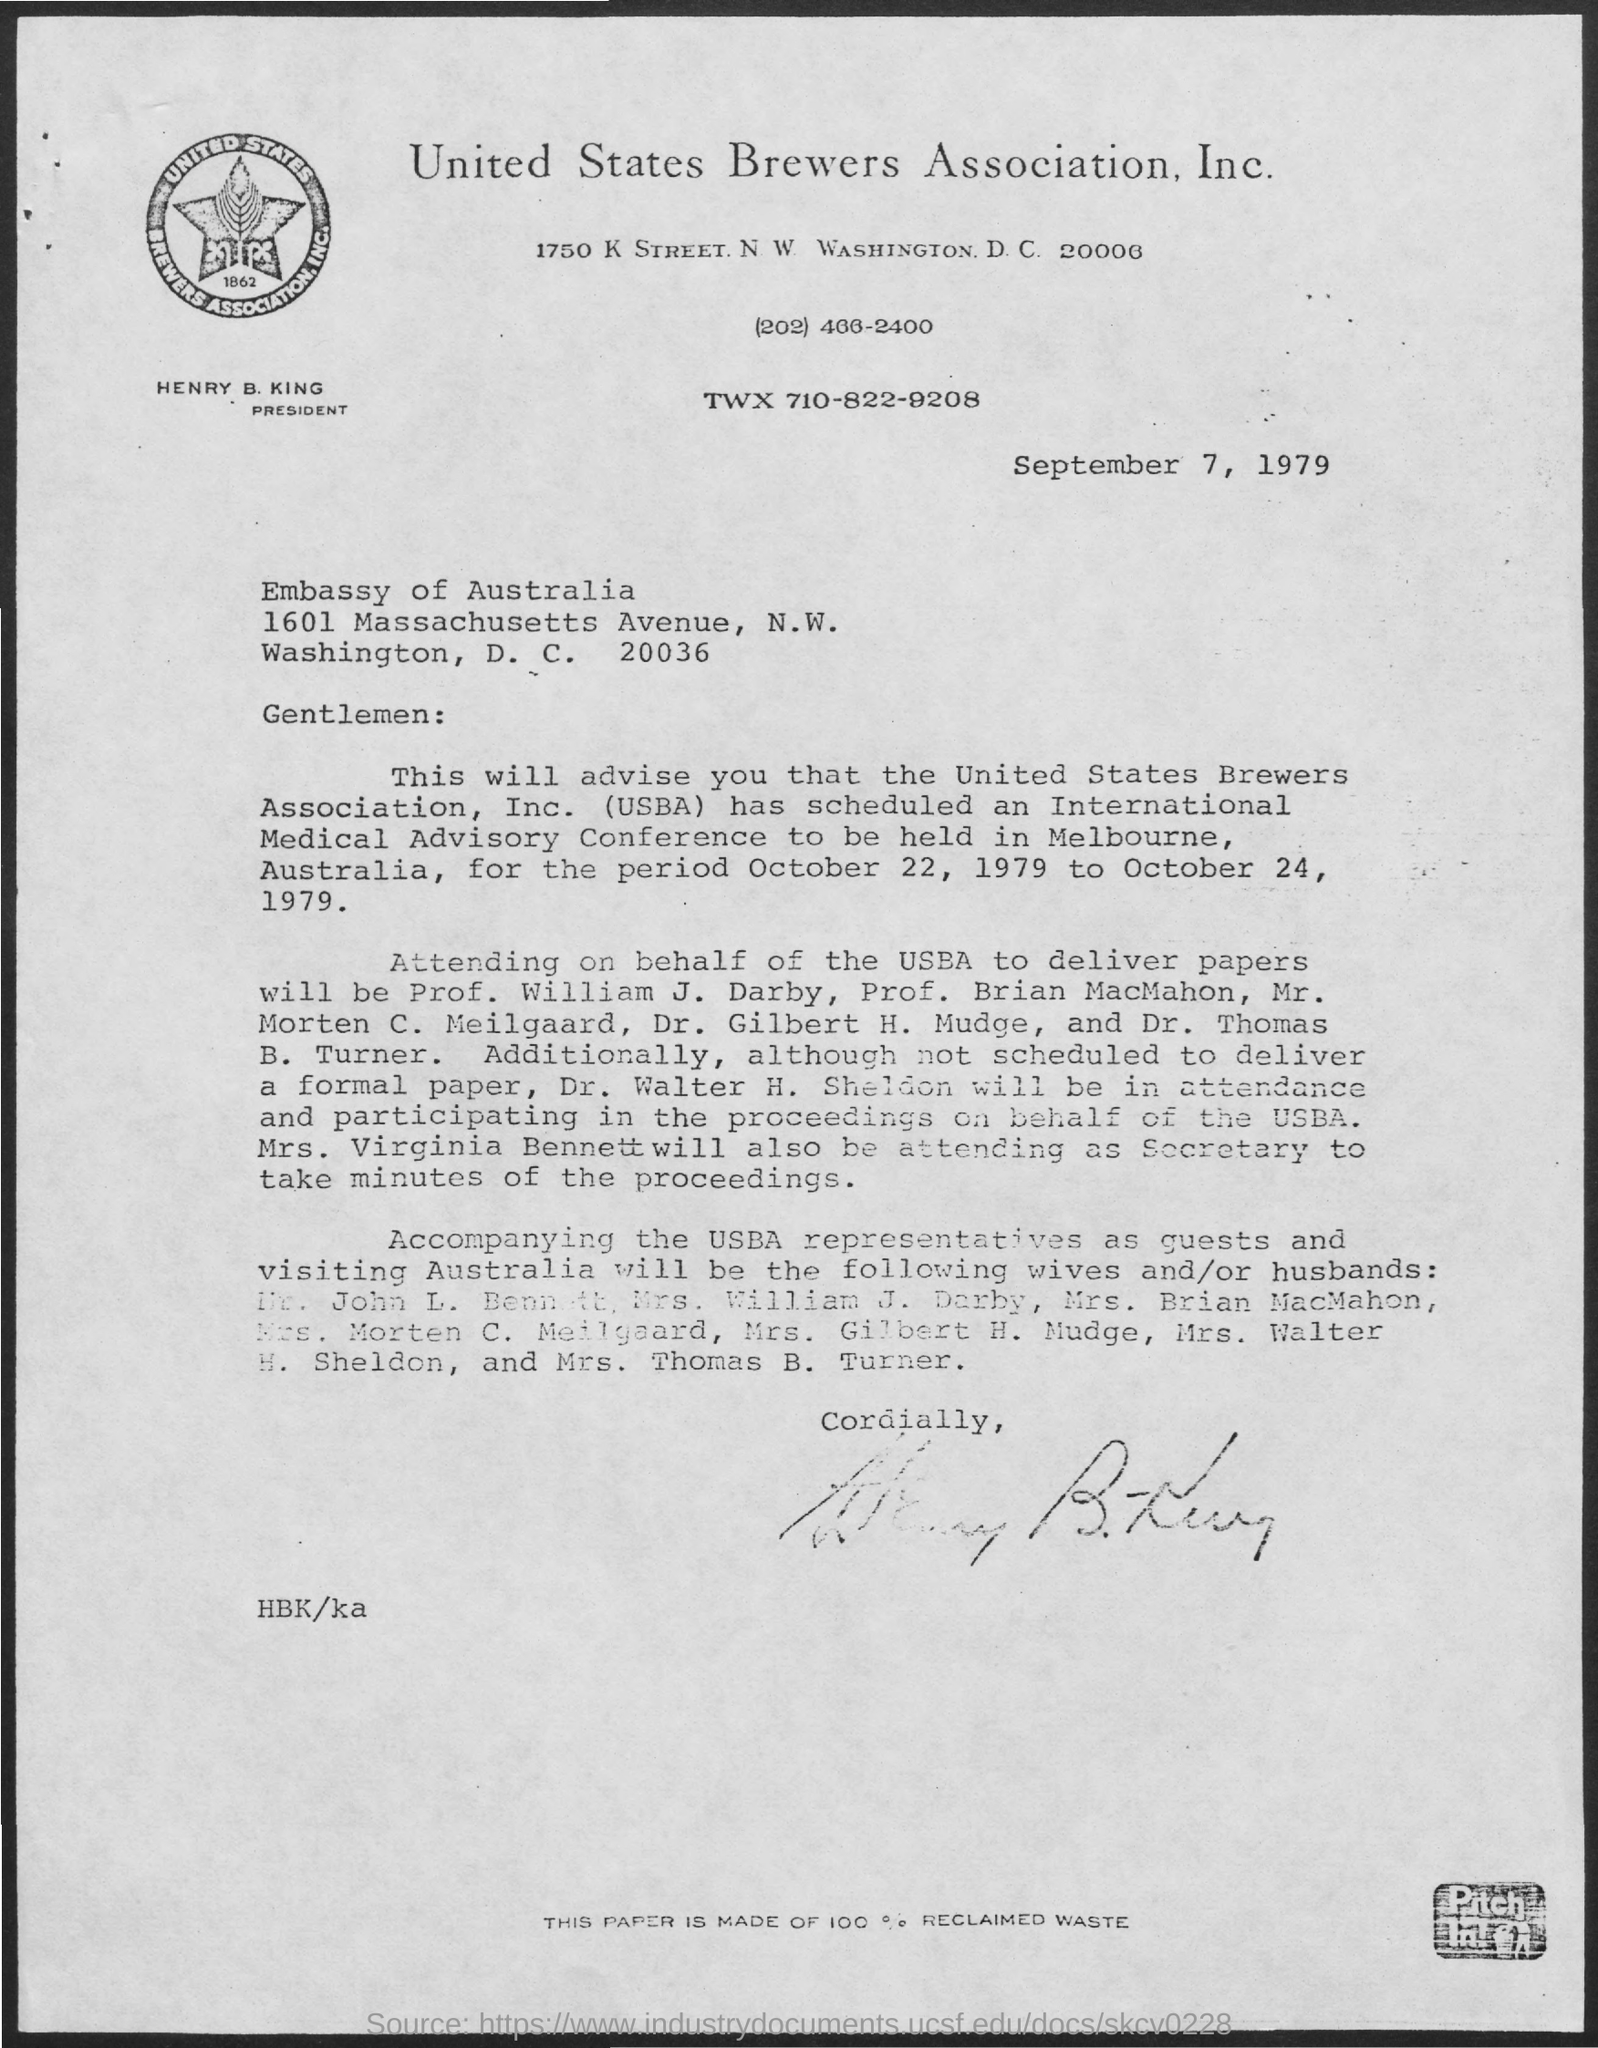What is the name of the association?
Offer a terse response. United States Brewers Association, Inc. What is the name of the President of the Association?
Ensure brevity in your answer.  Henry B. King. What is the date mentioned at the start of the document?
Ensure brevity in your answer.  September 7, 1979. 